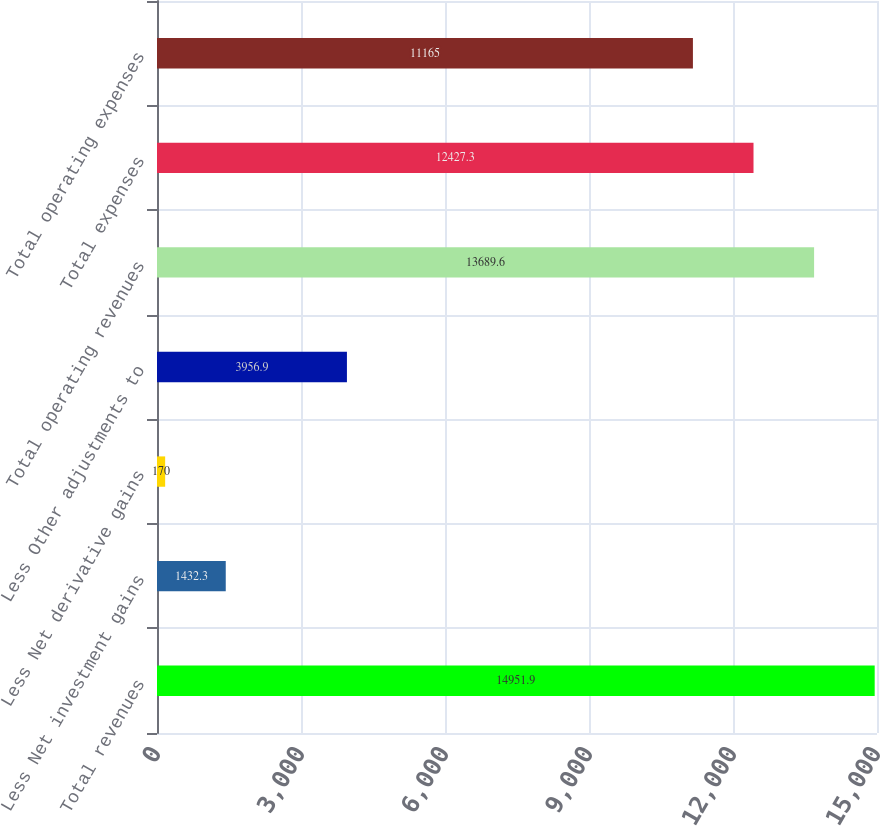Convert chart to OTSL. <chart><loc_0><loc_0><loc_500><loc_500><bar_chart><fcel>Total revenues<fcel>Less Net investment gains<fcel>Less Net derivative gains<fcel>Less Other adjustments to<fcel>Total operating revenues<fcel>Total expenses<fcel>Total operating expenses<nl><fcel>14951.9<fcel>1432.3<fcel>170<fcel>3956.9<fcel>13689.6<fcel>12427.3<fcel>11165<nl></chart> 